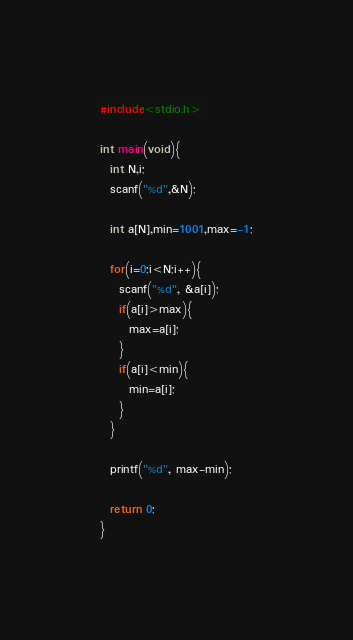Convert code to text. <code><loc_0><loc_0><loc_500><loc_500><_C_>#include<stdio.h>
 
int main(void){
  int N,i;
  scanf("%d",&N);
 
  int a[N],min=1001,max=-1;
 
  for(i=0;i<N;i++){
    scanf("%d", &a[i]);
    if(a[i]>max){
      max=a[i];
    }
    if(a[i]<min){
      min=a[i];
    }
  }
 
  printf("%d", max-min);
 
  return 0;
}</code> 